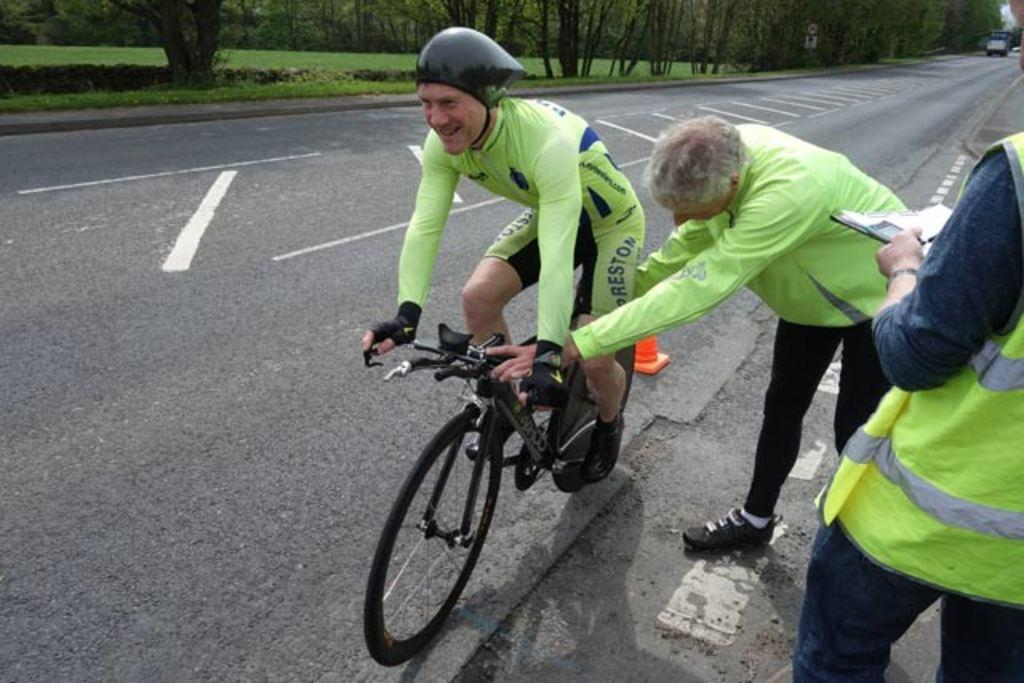Who is the main subject in the image? There is a man in the image. What is the man doing in the image? The man is riding a bicycle. What can be seen in the background of the image? There are trees and a road visible in the background. What type of drug is the man carrying in the image? There is no drug present in the image; the man is riding a bicycle and there is no indication of any drug. 